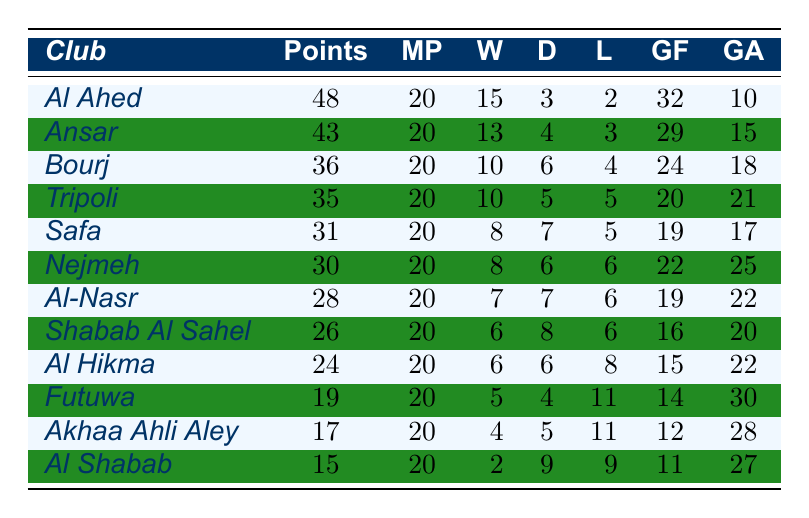How many points does Al Ahed have? Al Ahed is listed in the first row of the table, showing their points as 48.
Answer: 48 Which club has the highest number of wins? By examining the table, Al Ahed has the highest wins with 15, found in the Wins column.
Answer: Al Ahed What is the goal difference for Ansar? Ansar's Goals For is 29 and Goals Against is 15, so the goal difference is calculated as 29 - 15 = 14.
Answer: 14 What is the total number of goals scored by all clubs combined? The total is calculated by summing all the Goals For: 32 + 29 + 24 + 20 + 19 + 22 + 19 + 16 + 15 + 14 + 12 + 11 =  20 + 19 + 22 + 19 + 16 + 15 + 14 + 12 + 11 =  32 + 29 + 24 + 20 + 19 + 22 + 19 + 16 + 15 + 14 + 12 + 11 =  32 + 29 + 24 + 20 + 19 + 22 + 19 + 16 + 15 + 14 + 12 + 11 =  32 + 29 + 24 + 20 + 19 + 22 + 19 + 16 + 15 + 14 + 12 + 11 =  32 + 29 + 24 + 20 + 19 + 22 + 19 + 16 + 15 + 14 + 12 + 11 =  32 + 29 + 24 + 20 + 19 + 22 + 19 + 16 + 15 + 14 + 12 + 11 =  32 + 29 + 24 + 20 + 19 + 22 + 19 + 16 + 15 + 14 + 12 + 11 =  32 + 29 + 24 + 20 + 19 + 22 + 19 + 16 + 15 + 14 + 12 + 11 = 32 + 29 + 24 + 20 + 19 + 22 + 19 + 16 + 15 + 14 + 12 + 11 . The final sum is 290.
Answer: 290 Which club has the lowest points total? By looking at the Points column, Al Shabab has the lowest at 15, as it's listed at the bottom of the table.
Answer: Al Shabab Is it true that Tripoli has more goals against than goals for? Tripoli's Goals For is 20 and Goals Against is 21. Since 21 is greater than 20, this statement is true.
Answer: Yes What is the average number of draws among all clubs? The total number of draws is calculated by adding the draws: 3 + 4 + 6 + 5 + 7 + 6 + 7 + 8 + 6 + 4 + 5 + 9 = 60. There are 12 clubs, so the average is 60 / 12 = 5.
Answer: 5 Which club has a better defensive record, Safa or Nejmeh? Safa has Goals Against of 17 and Nejmeh has 25. Since 17 is less than 25, Safa has a better defensive record.
Answer: Safa If Futuwa won 3 more matches, how many points would they have? Currently, Futuwa has 19 points with 5 wins. If they win 3 more matches, they will have 5 + 3 = 8 wins. The points would increase by 3 for each win, so their new total would be 19 + 3 * 3 = 28 points.
Answer: 28 How many total losses did all clubs have combined? The total losses are calculated by summing the Losses column: 2 + 3 + 4 + 5 + 5 + 6 + 6 + 6 + 8 + 11 + 11 + 9 = 66.
Answer: 66 